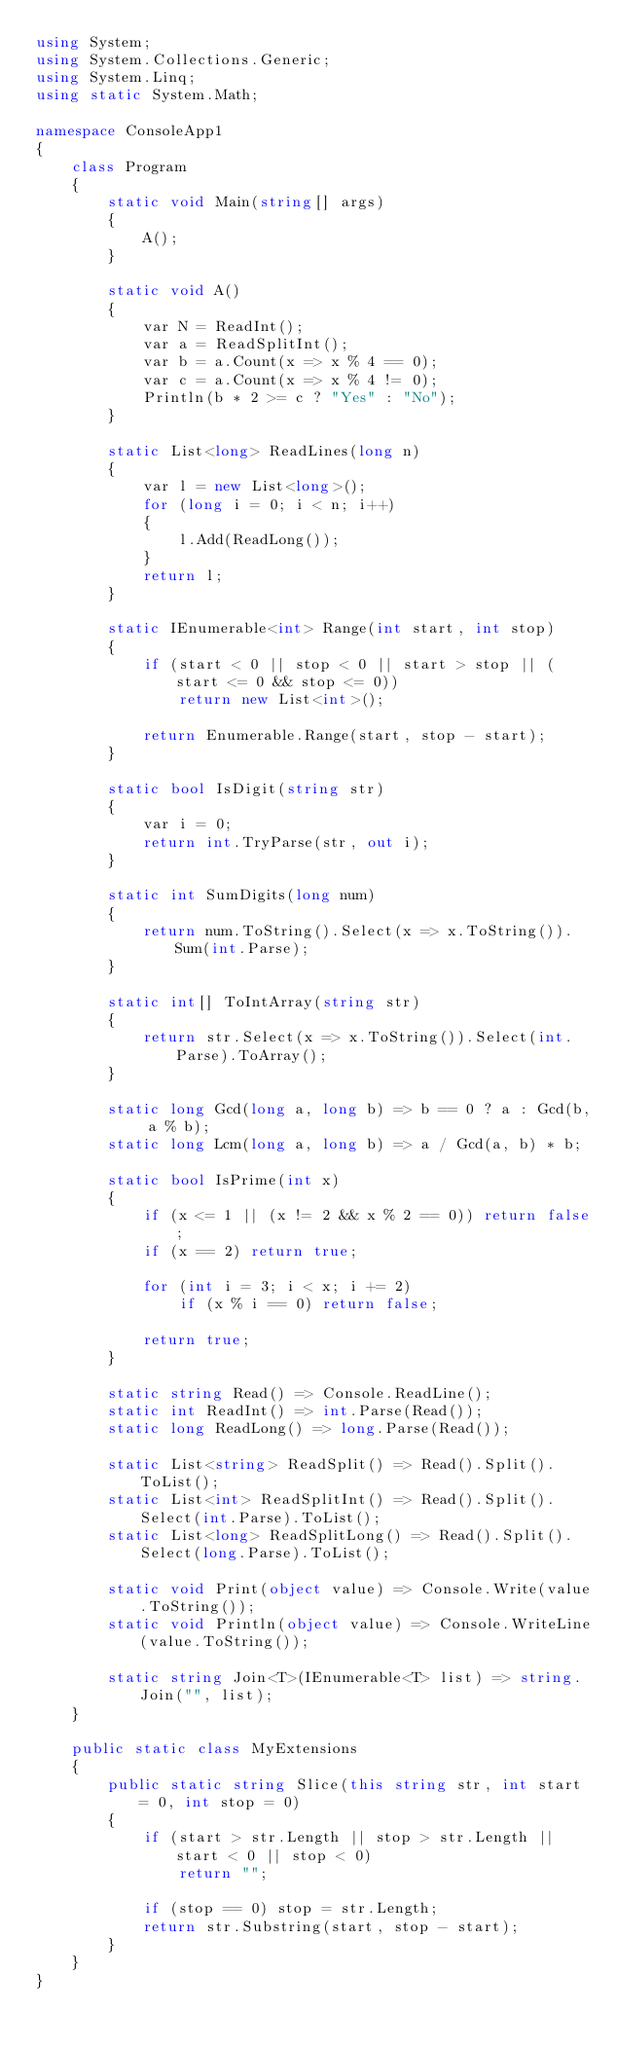<code> <loc_0><loc_0><loc_500><loc_500><_C#_>using System;
using System.Collections.Generic;
using System.Linq;
using static System.Math;

namespace ConsoleApp1
{
    class Program
    {
        static void Main(string[] args)
        {
            A();
        }

        static void A()
        {
            var N = ReadInt();
            var a = ReadSplitInt();
            var b = a.Count(x => x % 4 == 0);
            var c = a.Count(x => x % 4 != 0);
            Println(b * 2 >= c ? "Yes" : "No");
        }

        static List<long> ReadLines(long n)
        {
            var l = new List<long>();
            for (long i = 0; i < n; i++)
            {
                l.Add(ReadLong());
            }
            return l;
        }

        static IEnumerable<int> Range(int start, int stop)
        {
            if (start < 0 || stop < 0 || start > stop || (start <= 0 && stop <= 0))
                return new List<int>();

            return Enumerable.Range(start, stop - start);
        }

        static bool IsDigit(string str)
        {
            var i = 0;
            return int.TryParse(str, out i);
        }

        static int SumDigits(long num)
        {
            return num.ToString().Select(x => x.ToString()).Sum(int.Parse);
        }

        static int[] ToIntArray(string str)
        {
            return str.Select(x => x.ToString()).Select(int.Parse).ToArray();
        }

        static long Gcd(long a, long b) => b == 0 ? a : Gcd(b, a % b);
        static long Lcm(long a, long b) => a / Gcd(a, b) * b;

        static bool IsPrime(int x)
        {
            if (x <= 1 || (x != 2 && x % 2 == 0)) return false;
            if (x == 2) return true;

            for (int i = 3; i < x; i += 2)
                if (x % i == 0) return false;

            return true;
        }

        static string Read() => Console.ReadLine();
        static int ReadInt() => int.Parse(Read());
        static long ReadLong() => long.Parse(Read());

        static List<string> ReadSplit() => Read().Split().ToList();
        static List<int> ReadSplitInt() => Read().Split().Select(int.Parse).ToList();
        static List<long> ReadSplitLong() => Read().Split().Select(long.Parse).ToList();

        static void Print(object value) => Console.Write(value.ToString());
        static void Println(object value) => Console.WriteLine(value.ToString());

        static string Join<T>(IEnumerable<T> list) => string.Join("", list);
    }

    public static class MyExtensions
    {
        public static string Slice(this string str, int start = 0, int stop = 0)
        {
            if (start > str.Length || stop > str.Length || start < 0 || stop < 0)
                return "";

            if (stop == 0) stop = str.Length;
            return str.Substring(start, stop - start);
        }
    }
}</code> 